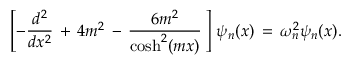<formula> <loc_0><loc_0><loc_500><loc_500>\left [ - \frac { d ^ { 2 } } { d x ^ { 2 } } \, + \, 4 m ^ { 2 } \, - \, \frac { 6 m ^ { 2 } } { \cosh ^ { 2 } ( m x ) } \, \right ] \, \psi _ { n } ( x ) \, = \, \omega _ { n } ^ { 2 } \psi _ { n } ( x ) .</formula> 